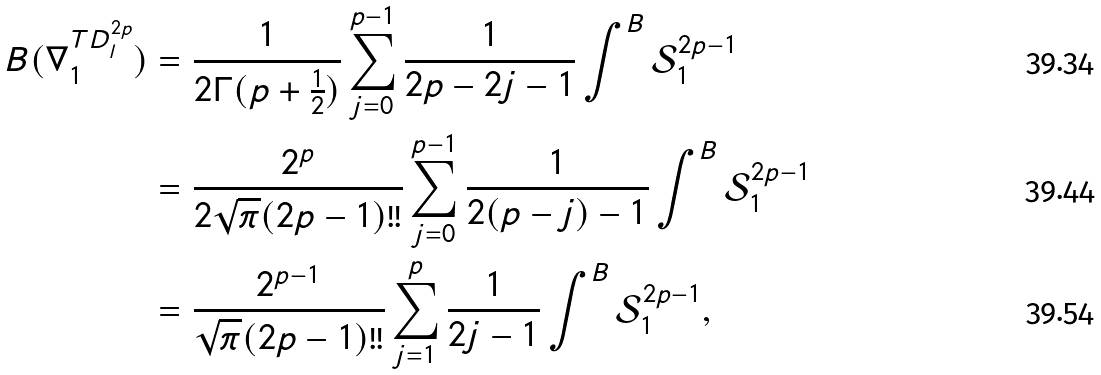<formula> <loc_0><loc_0><loc_500><loc_500>B ( \nabla _ { 1 } ^ { T D ^ { 2 p } _ { l } } ) & = \frac { 1 } { 2 \Gamma ( p + \frac { 1 } { 2 } ) } \sum _ { j = 0 } ^ { p - 1 } \frac { 1 } { 2 p - 2 j - 1 } \int ^ { B } \mathcal { S } _ { 1 } ^ { 2 p - 1 } \\ & = \frac { 2 ^ { p } } { 2 \sqrt { \pi } ( 2 p - 1 ) ! ! } \sum _ { j = 0 } ^ { p - 1 } \frac { 1 } { 2 ( p - j ) - 1 } \int ^ { B } \mathcal { S } _ { 1 } ^ { 2 p - 1 } \\ & = \frac { 2 ^ { p - 1 } } { \sqrt { \pi } ( 2 p - 1 ) ! ! } \sum _ { j = 1 } ^ { p } \frac { 1 } { 2 j - 1 } \int ^ { B } \mathcal { S } _ { 1 } ^ { 2 p - 1 } ,</formula> 